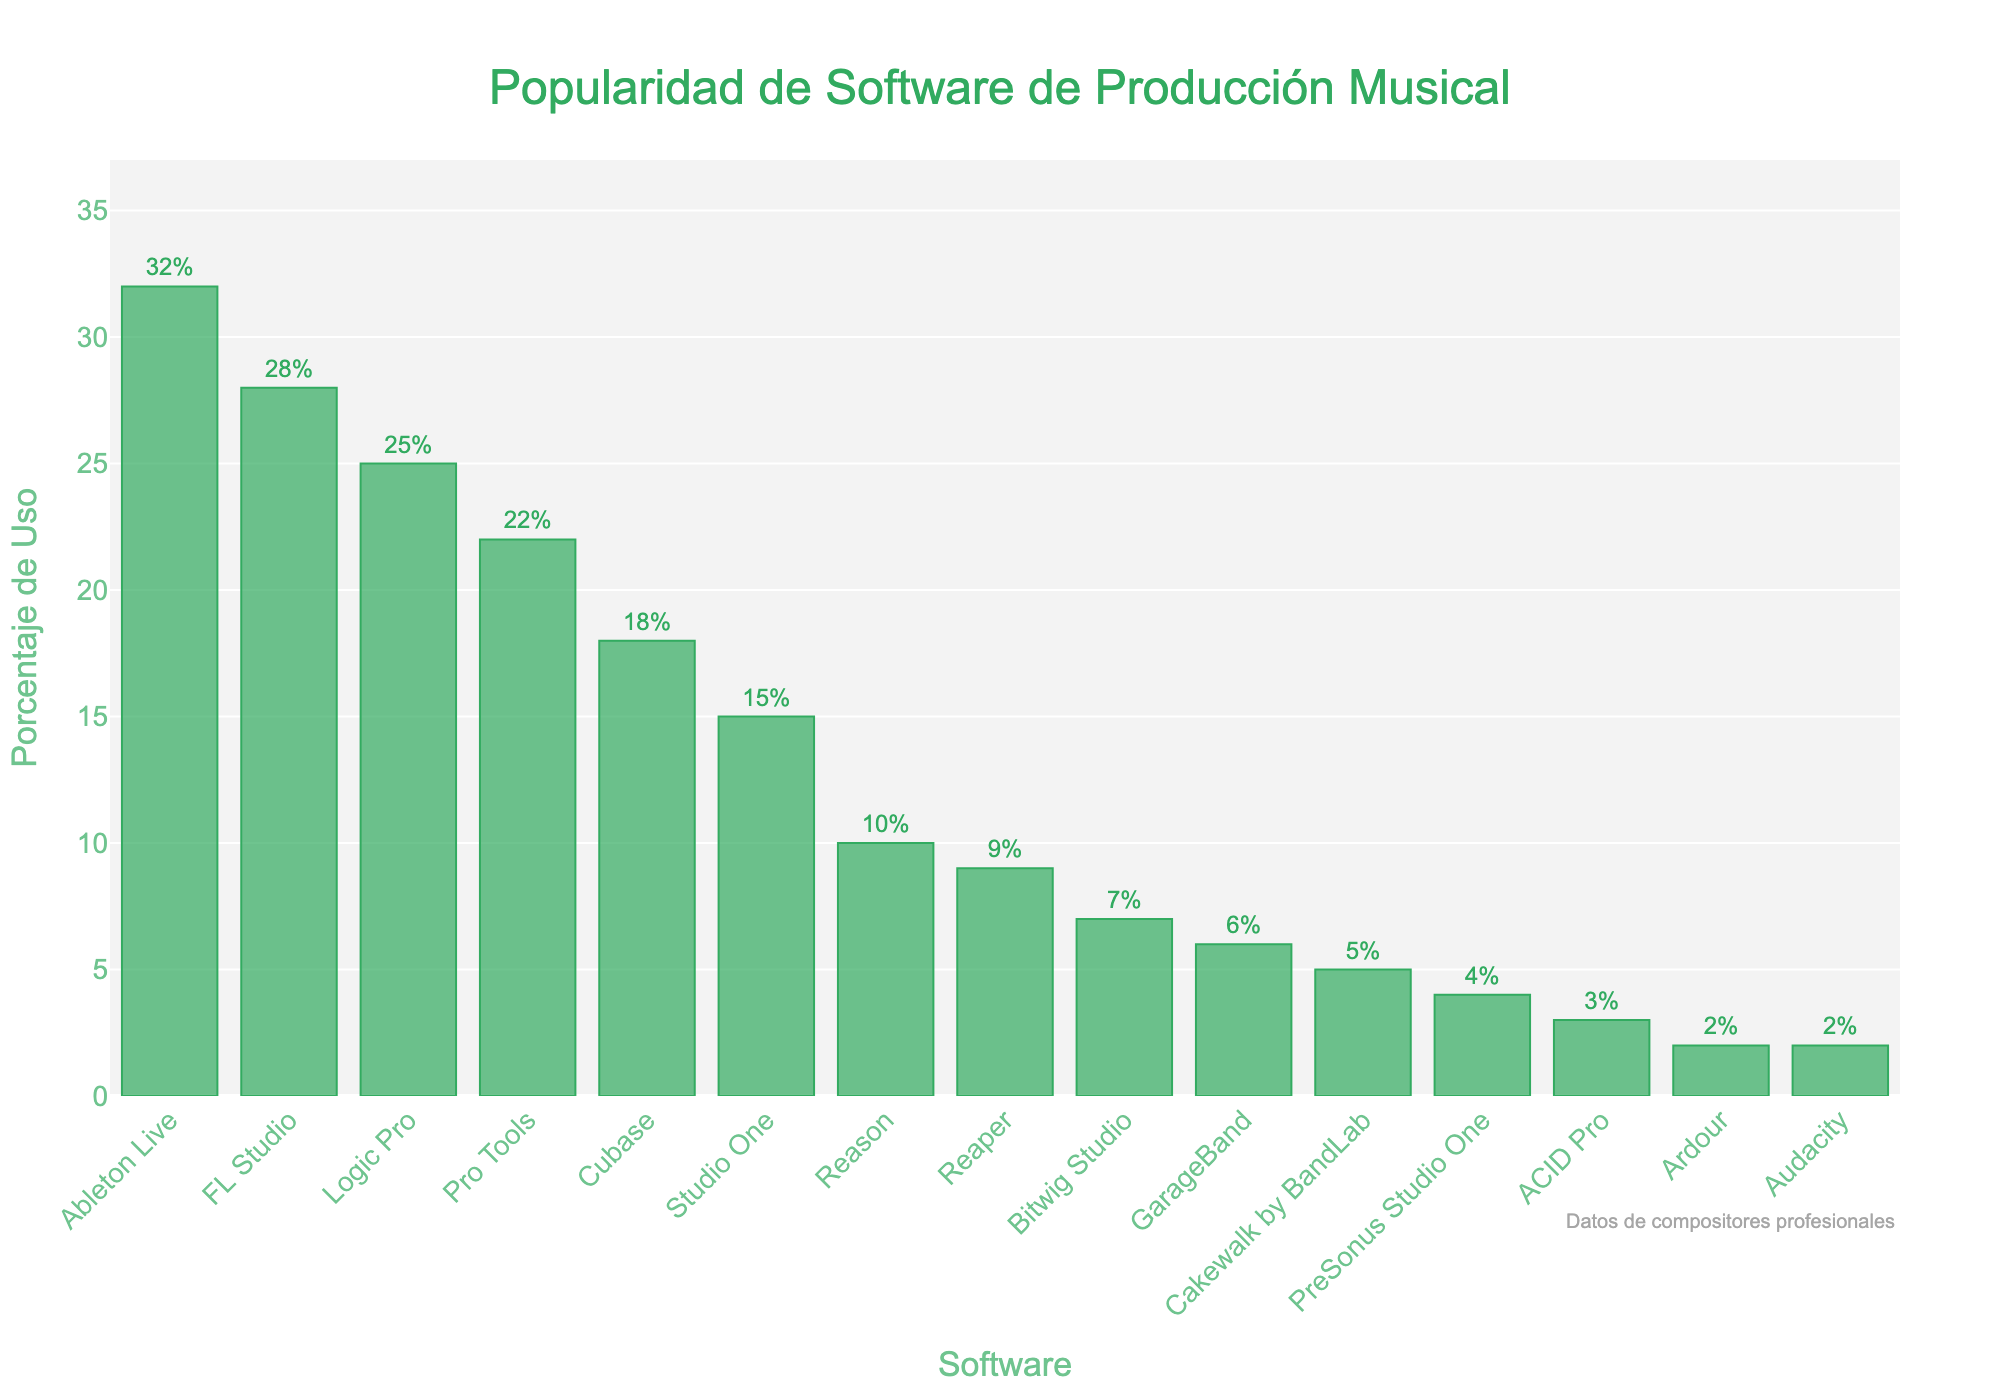Which software is the most popular among composers? By looking at the highest bar in the chart, which represents the highest percentage, we can determine the most popular software. In this case, the highest bar corresponds to "Ableton Live".
Answer: Ableton Live What is the difference in usage percentage between FL Studio and Logic Pro? The bar for FL Studio shows a percentage of 28, and the bar for Logic Pro shows 25. Subtracting the smaller percentage from the larger one gives us the difference. 28 - 25 = 3
Answer: 3 How much more popular is Ableton Live compared to Reason? The bar for Ableton Live indicates a usage percentage of 32, and the bar for Reason is 10. Subtracting the percentage for Reason from Ableton Live's percentage gives us the difference. 32 - 10 = 22
Answer: 22 What is the total usage percentage of the three least popular software? The three least popular software are Ardour, Audacity, and ACID Pro with percentages of 2, 2, and 3 respectively. Summing these values gives us the total. 2 + 2 + 3 = 7
Answer: 7 Which software has a higher usage percentage: Studio One or Cubase? By comparing the length of the bars representing Studio One and Cubase, we see that Cubase has a higher percentage (18) compared to Studio One (15).
Answer: Cubase What is the average usage percentage of Bitwig Studio and GarageBand? The usage percentage for Bitwig Studio is 7 and for GarageBand is 6. Summing these values and dividing by 2 gives us the average. (7 + 6) / 2 = 6.5
Answer: 6.5 By how much does the percentage of usage of Pro Tools exceed that of Reaper? The bar for Pro Tools shows a percentage of 22, and the bar for Reaper shows 9. Subtracting the smaller percentage from the larger one gives us the difference. 22 - 9 = 13
Answer: 13 What is the combined usage percentage of Logic Pro, Pro Tools, and Cubase? Adding the usage percentages for Logic Pro, Pro Tools, and Cubase gives us the total. 25 + 22 + 18 = 65
Answer: 65 